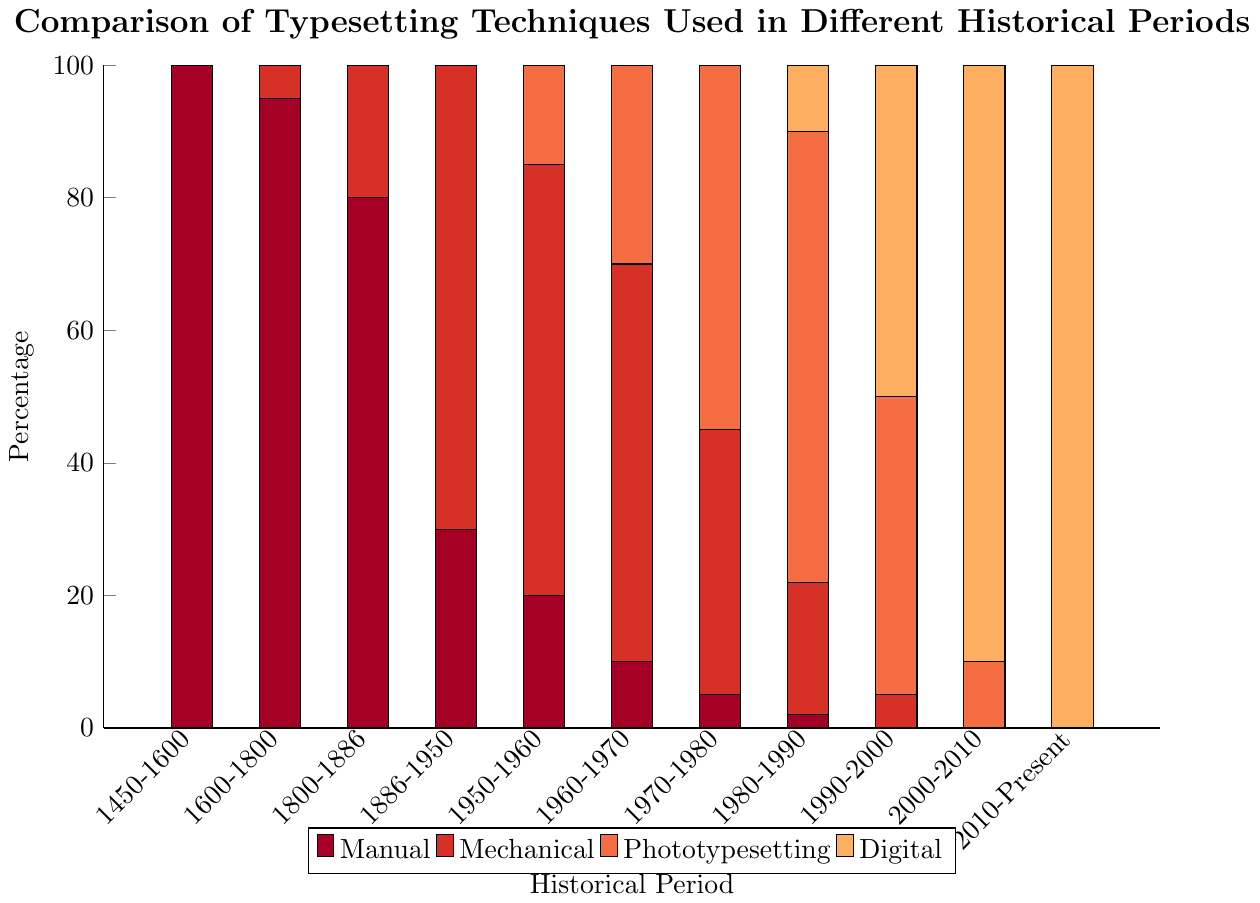Which period shows the highest percentage of manual typesetting? The bar for manual typesetting is highest for the period 1450-1600, reaching the top value of 100%.
Answer: 1450-1600 How does the usage of phototypesetting change from 1886-1950 to 2010-Present? Phototypesetting starts from 0% in 1886-1950 and eventually drops back to 0% in 2010-Present. It increases in percentages reaching peaks in the 1970s and starts decreasing afterward.
Answer: It grows and then declines back to 0% Which typesetting technique is dominant in the period 1950-1960? By analyzing the stacked bars, mechanical typesetting occupies the largest portion for the period 1950-1960 with 65%.
Answer: Mechanical In which period does digital typesetting first appear and what is its initial percentage? The green bar representing digital typesetting first appears in the period 1980-1990 with a value of 10%.
Answer: 1980-1990, 10% Between which periods did mechanical typesetting see its largest decrease in percentage? The percentage of mechanical typesetting sees its largest decrease from 60% in 1960-1970 to 40% in 1970-1980, a difference of 20%.
Answer: 1960-1970 to 1970-1980 Which period shows an equal percentage of manual and phototypesetting? For the period 1980-1990, the blue bar (manual) is at 2% and the orange bar (phototypesetting) is also at 2%. However, the period does not actually show an equal percentage for these two categories as manual is higher than phototypesetting. No period actually shows equality.
Answer: No period How does the percentage of mechanical typesetting change from 1600-1800 to 1800-1886? Mechanical typesetting grows from 5% in 1600-1800 to 20% in 1800-1886, an increase of 15 percentage points.
Answer: Increases by 15% What's the general trend of digital typesetting from 1980-1990 onwards? Digital typesetting starts at 10% in 1980-1990, rises to 50% in 1990-2000, then 90% in 2000-2010, and finally reaches 100% in 2010-Present, showing a steady increase over time.
Answer: Steady increase In the period 1970-1980, which typesetting techniques are used and what are their respective percentages? In the period 1970-1980, manual typesetting is at 5%, mechanical at 40%, and phototypesetting at 55%. No digital typesetting is used yet.
Answer: Manual: 5%, Mechanical: 40%, Phototypesetting: 55%, Digital: 0% 